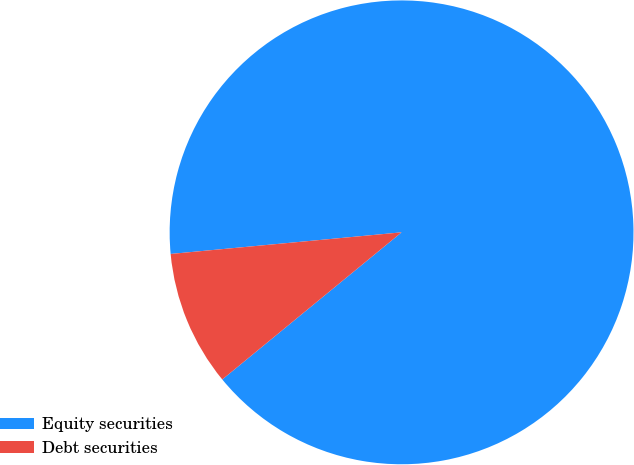Convert chart. <chart><loc_0><loc_0><loc_500><loc_500><pie_chart><fcel>Equity securities<fcel>Debt securities<nl><fcel>90.55%<fcel>9.45%<nl></chart> 